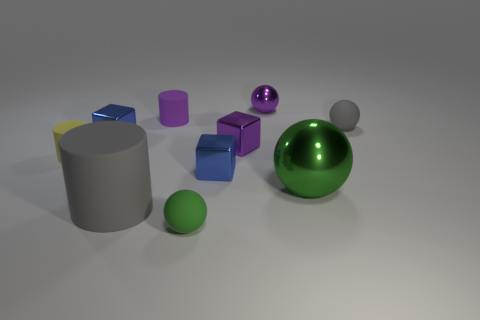Subtract all tiny cylinders. How many cylinders are left? 1 Subtract all purple balls. How many balls are left? 3 Subtract all balls. How many objects are left? 6 Subtract 2 cylinders. How many cylinders are left? 1 Subtract all gray balls. How many brown blocks are left? 0 Subtract all brown metallic objects. Subtract all yellow cylinders. How many objects are left? 9 Add 3 yellow rubber objects. How many yellow rubber objects are left? 4 Add 6 tiny green rubber things. How many tiny green rubber things exist? 7 Subtract 1 purple blocks. How many objects are left? 9 Subtract all green cubes. Subtract all gray cylinders. How many cubes are left? 3 